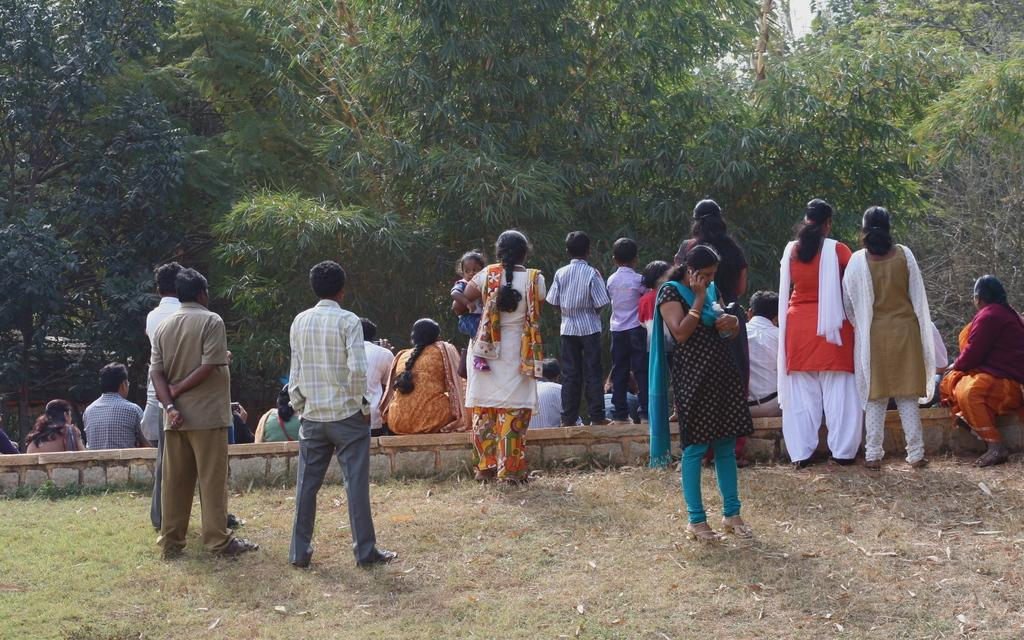What is at the bottom of the image? There is ground at the bottom of the image. What are the people in the image doing? Some people are sitting, and others are standing in a standing position in the image. What is in the foreground of the image? There is a wall in the foreground of the image. What can be seen in the background of the image? There are trees in the background of the image. What is visible at the top of the image? The sky is visible at the top of the image. How many grapes are being used as a boundary in the image? There are no grapes present in the image, nor are they being used as a boundary. 